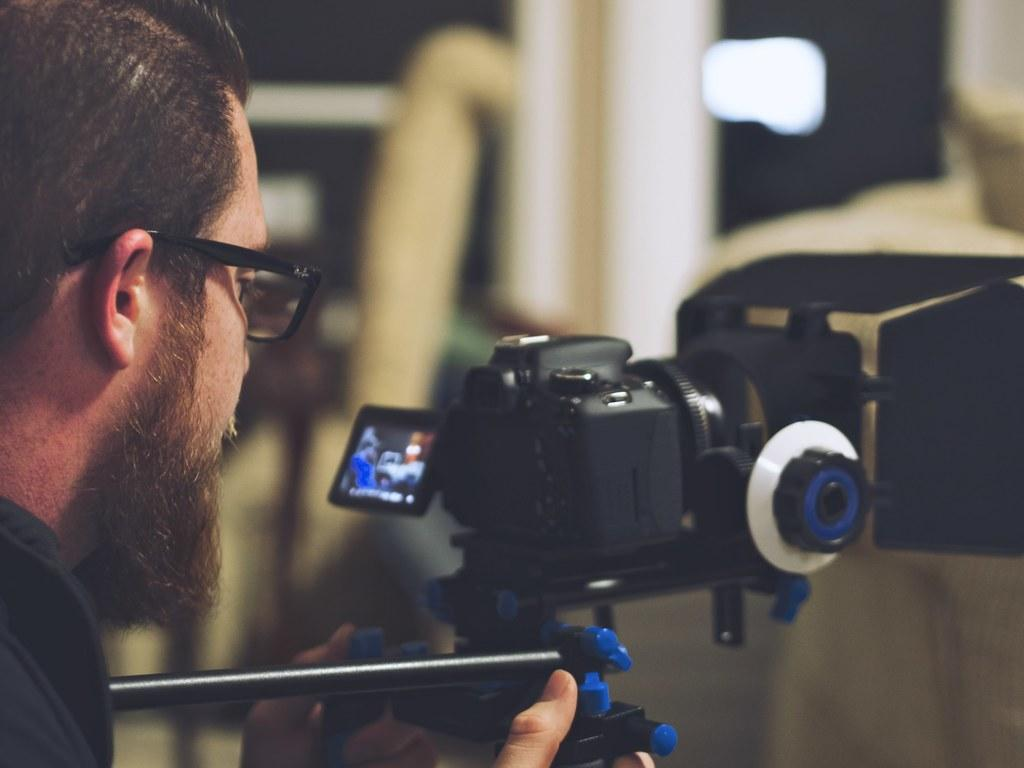Who is the main subject in the image? There is a man in the image. What is the man holding in the image? The man is holding a camera. What else can be seen in the image besides the man and the camera? There is a screen visible in the image. What accessory is the man wearing in the image? The man is wearing glasses. What type of beast can be seen attempting to eat the man's glasses in the image? There is no beast present in the image, and the man's glasses are not being eaten by any creature. 